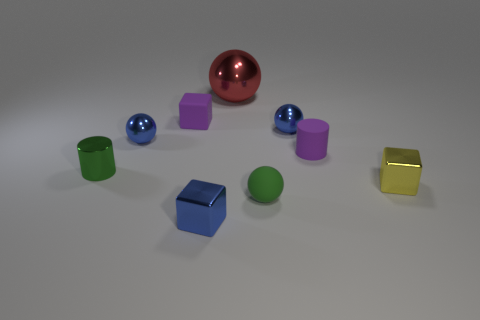What is the color of the small matte thing that is the same shape as the big red thing?
Offer a terse response. Green. Are there any other things that have the same color as the tiny matte block?
Offer a very short reply. Yes. There is a metallic object in front of the tiny yellow thing; is it the same size as the block behind the green metallic cylinder?
Offer a terse response. Yes. Is the number of tiny metal blocks that are on the right side of the tiny green matte thing the same as the number of large spheres behind the red shiny sphere?
Your answer should be very brief. No. There is a green cylinder; is it the same size as the blue metallic ball right of the small green matte ball?
Provide a short and direct response. Yes. Are there any large red balls that are in front of the matte object that is in front of the tiny green metal thing?
Offer a terse response. No. Are there any tiny yellow objects that have the same shape as the big metal thing?
Make the answer very short. No. How many metallic things are in front of the cylinder to the left of the block in front of the yellow metal object?
Offer a terse response. 2. Do the tiny rubber ball and the small cylinder that is behind the green cylinder have the same color?
Your answer should be compact. No. What number of things are either small blue objects that are in front of the tiny green metal object or shiny objects that are behind the tiny green shiny thing?
Your response must be concise. 4. 